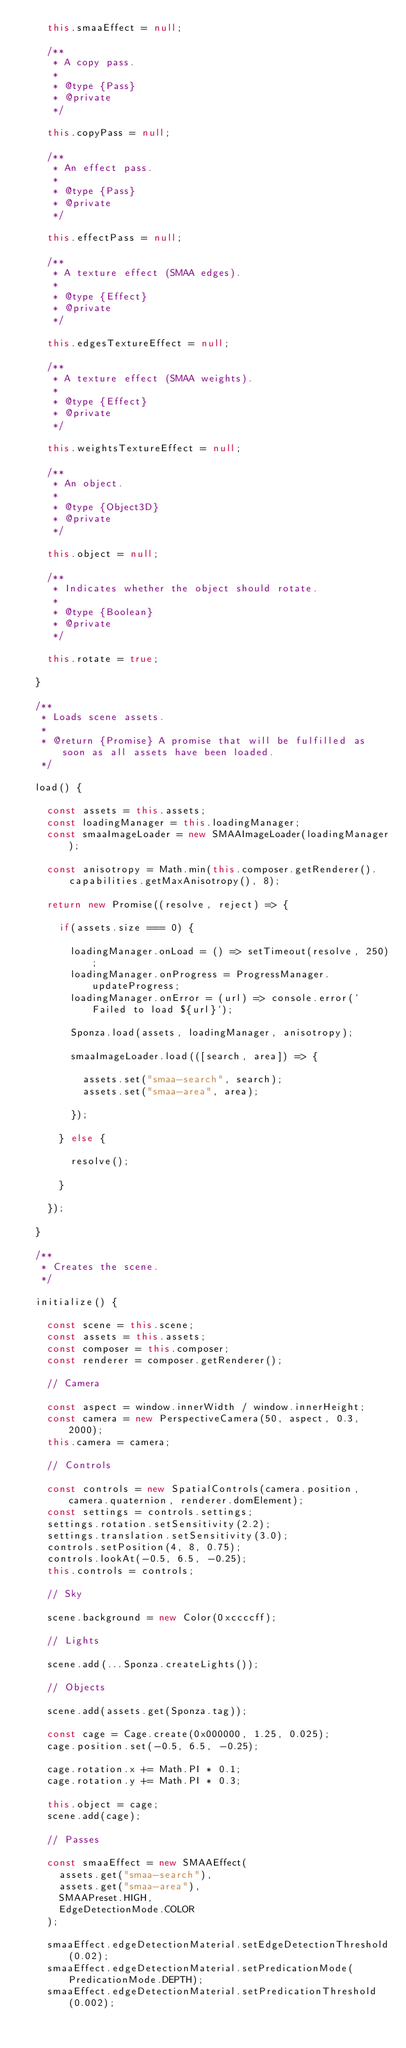Convert code to text. <code><loc_0><loc_0><loc_500><loc_500><_JavaScript_>		this.smaaEffect = null;

		/**
		 * A copy pass.
		 *
		 * @type {Pass}
		 * @private
		 */

		this.copyPass = null;

		/**
		 * An effect pass.
		 *
		 * @type {Pass}
		 * @private
		 */

		this.effectPass = null;

		/**
		 * A texture effect (SMAA edges).
		 *
		 * @type {Effect}
		 * @private
		 */

		this.edgesTextureEffect = null;

		/**
		 * A texture effect (SMAA weights).
		 *
		 * @type {Effect}
		 * @private
		 */

		this.weightsTextureEffect = null;

		/**
		 * An object.
		 *
		 * @type {Object3D}
		 * @private
		 */

		this.object = null;

		/**
		 * Indicates whether the object should rotate.
		 *
		 * @type {Boolean}
		 * @private
		 */

		this.rotate = true;

	}

	/**
	 * Loads scene assets.
	 *
	 * @return {Promise} A promise that will be fulfilled as soon as all assets have been loaded.
	 */

	load() {

		const assets = this.assets;
		const loadingManager = this.loadingManager;
		const smaaImageLoader = new SMAAImageLoader(loadingManager);

		const anisotropy = Math.min(this.composer.getRenderer().capabilities.getMaxAnisotropy(), 8);

		return new Promise((resolve, reject) => {

			if(assets.size === 0) {

				loadingManager.onLoad = () => setTimeout(resolve, 250);
				loadingManager.onProgress = ProgressManager.updateProgress;
				loadingManager.onError = (url) => console.error(`Failed to load ${url}`);

				Sponza.load(assets, loadingManager, anisotropy);

				smaaImageLoader.load(([search, area]) => {

					assets.set("smaa-search", search);
					assets.set("smaa-area", area);

				});

			} else {

				resolve();

			}

		});

	}

	/**
	 * Creates the scene.
	 */

	initialize() {

		const scene = this.scene;
		const assets = this.assets;
		const composer = this.composer;
		const renderer = composer.getRenderer();

		// Camera

		const aspect = window.innerWidth / window.innerHeight;
		const camera = new PerspectiveCamera(50, aspect, 0.3, 2000);
		this.camera = camera;

		// Controls

		const controls = new SpatialControls(camera.position, camera.quaternion, renderer.domElement);
		const settings = controls.settings;
		settings.rotation.setSensitivity(2.2);
		settings.translation.setSensitivity(3.0);
		controls.setPosition(4, 8, 0.75);
		controls.lookAt(-0.5, 6.5, -0.25);
		this.controls = controls;

		// Sky

		scene.background = new Color(0xccccff);

		// Lights

		scene.add(...Sponza.createLights());

		// Objects

		scene.add(assets.get(Sponza.tag));

		const cage = Cage.create(0x000000, 1.25, 0.025);
		cage.position.set(-0.5, 6.5, -0.25);

		cage.rotation.x += Math.PI * 0.1;
		cage.rotation.y += Math.PI * 0.3;

		this.object = cage;
		scene.add(cage);

		// Passes

		const smaaEffect = new SMAAEffect(
			assets.get("smaa-search"),
			assets.get("smaa-area"),
			SMAAPreset.HIGH,
			EdgeDetectionMode.COLOR
		);

		smaaEffect.edgeDetectionMaterial.setEdgeDetectionThreshold(0.02);
		smaaEffect.edgeDetectionMaterial.setPredicationMode(PredicationMode.DEPTH);
		smaaEffect.edgeDetectionMaterial.setPredicationThreshold(0.002);</code> 